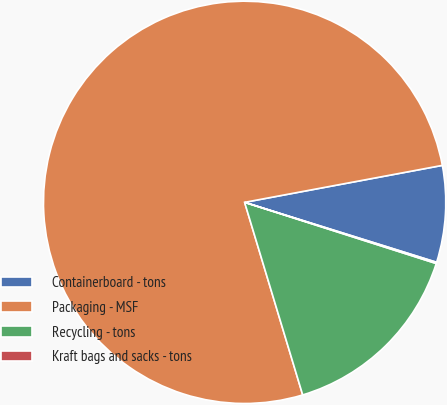Convert chart. <chart><loc_0><loc_0><loc_500><loc_500><pie_chart><fcel>Containerboard - tons<fcel>Packaging - MSF<fcel>Recycling - tons<fcel>Kraft bags and sacks - tons<nl><fcel>7.76%<fcel>76.72%<fcel>15.42%<fcel>0.1%<nl></chart> 